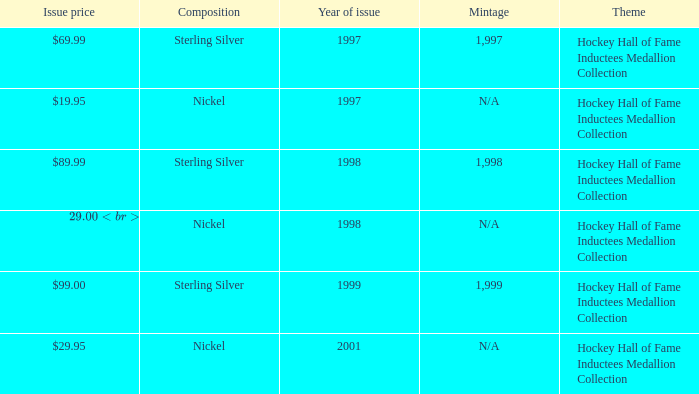Which composition has an issue price of $99.00? Sterling Silver. 